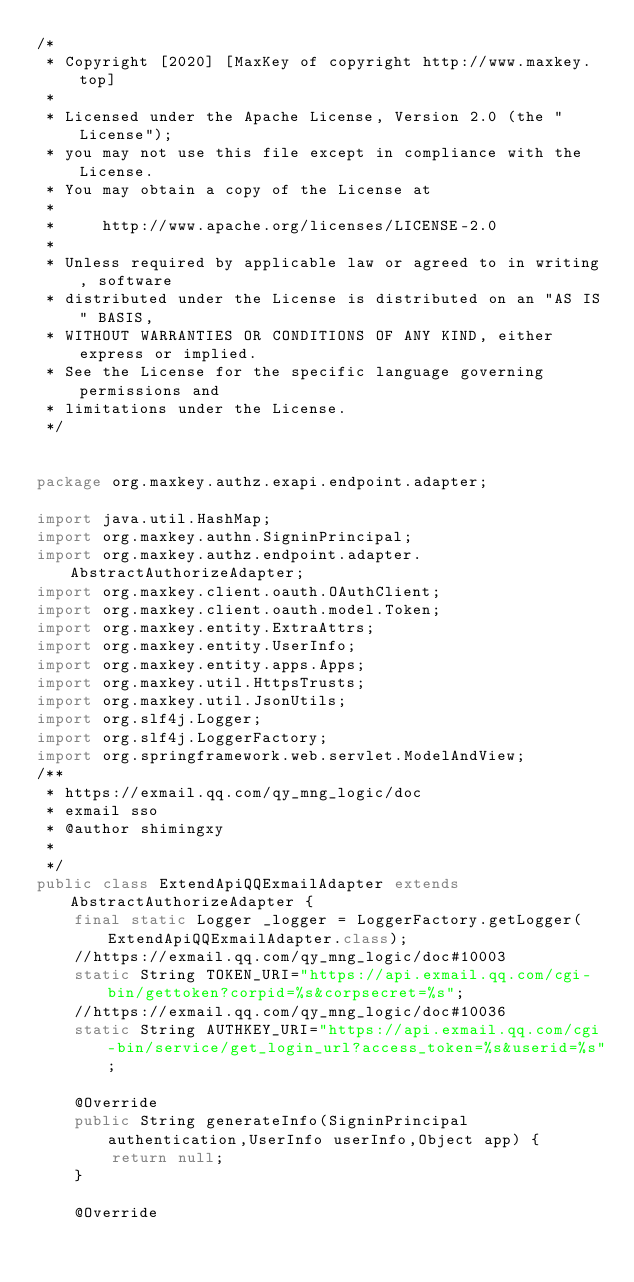Convert code to text. <code><loc_0><loc_0><loc_500><loc_500><_Java_>/*
 * Copyright [2020] [MaxKey of copyright http://www.maxkey.top]
 * 
 * Licensed under the Apache License, Version 2.0 (the "License");
 * you may not use this file except in compliance with the License.
 * You may obtain a copy of the License at
 * 
 *     http://www.apache.org/licenses/LICENSE-2.0
 * 
 * Unless required by applicable law or agreed to in writing, software
 * distributed under the License is distributed on an "AS IS" BASIS,
 * WITHOUT WARRANTIES OR CONDITIONS OF ANY KIND, either express or implied.
 * See the License for the specific language governing permissions and
 * limitations under the License.
 */
 

package org.maxkey.authz.exapi.endpoint.adapter;

import java.util.HashMap;
import org.maxkey.authn.SigninPrincipal;
import org.maxkey.authz.endpoint.adapter.AbstractAuthorizeAdapter;
import org.maxkey.client.oauth.OAuthClient;
import org.maxkey.client.oauth.model.Token;
import org.maxkey.entity.ExtraAttrs;
import org.maxkey.entity.UserInfo;
import org.maxkey.entity.apps.Apps;
import org.maxkey.util.HttpsTrusts;
import org.maxkey.util.JsonUtils;
import org.slf4j.Logger;
import org.slf4j.LoggerFactory;
import org.springframework.web.servlet.ModelAndView;
/**
 * https://exmail.qq.com/qy_mng_logic/doc
 * exmail sso
 * @author shimingxy
 *
 */
public class ExtendApiQQExmailAdapter extends AbstractAuthorizeAdapter {
	final static Logger _logger = LoggerFactory.getLogger(ExtendApiQQExmailAdapter.class);
	//https://exmail.qq.com/qy_mng_logic/doc#10003
	static String TOKEN_URI="https://api.exmail.qq.com/cgi-bin/gettoken?corpid=%s&corpsecret=%s";
	//https://exmail.qq.com/qy_mng_logic/doc#10036
	static String AUTHKEY_URI="https://api.exmail.qq.com/cgi-bin/service/get_login_url?access_token=%s&userid=%s";
	
	@Override
	public String generateInfo(SigninPrincipal authentication,UserInfo userInfo,Object app) {
		return null;
	}

	@Override</code> 